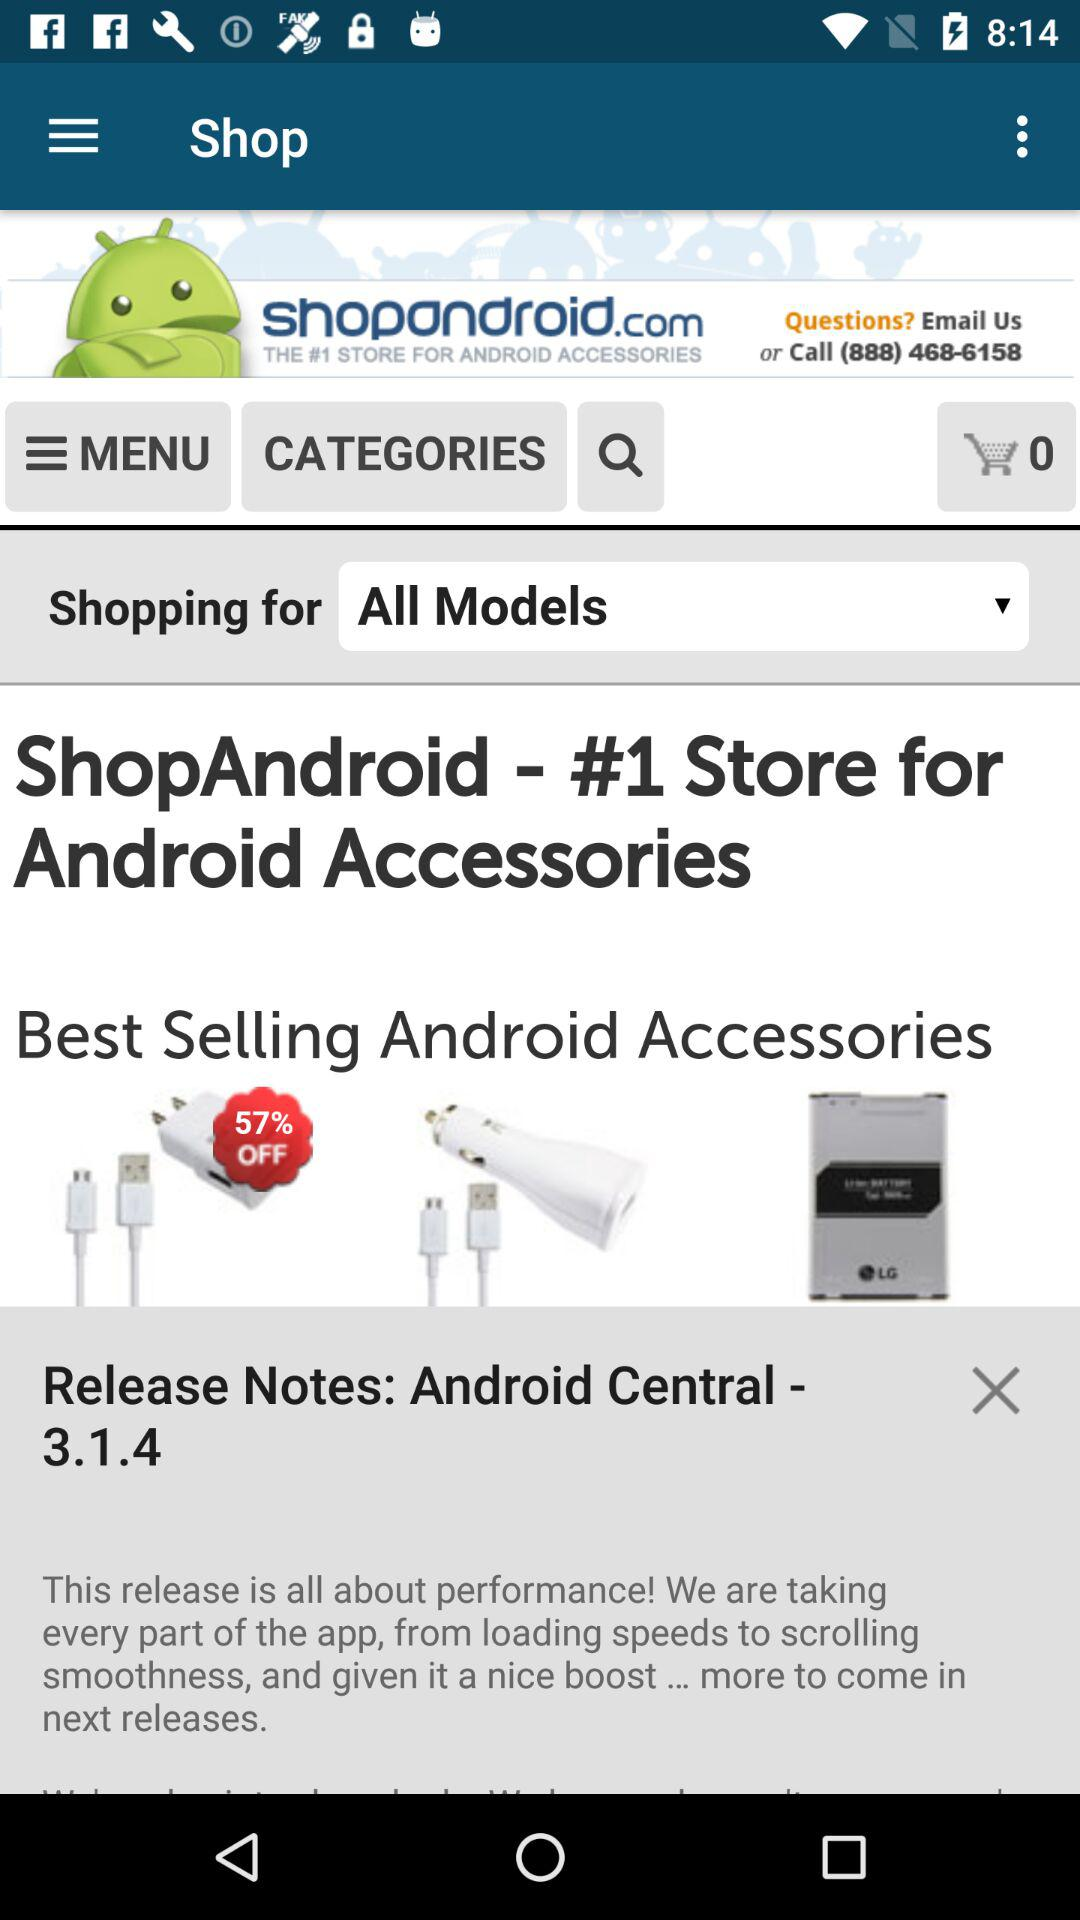Which option has been chosen for "Shopping for" from the drop-down menu? The option that has been chosen for "Shopping for" from the drop-down menu is "All Models". 